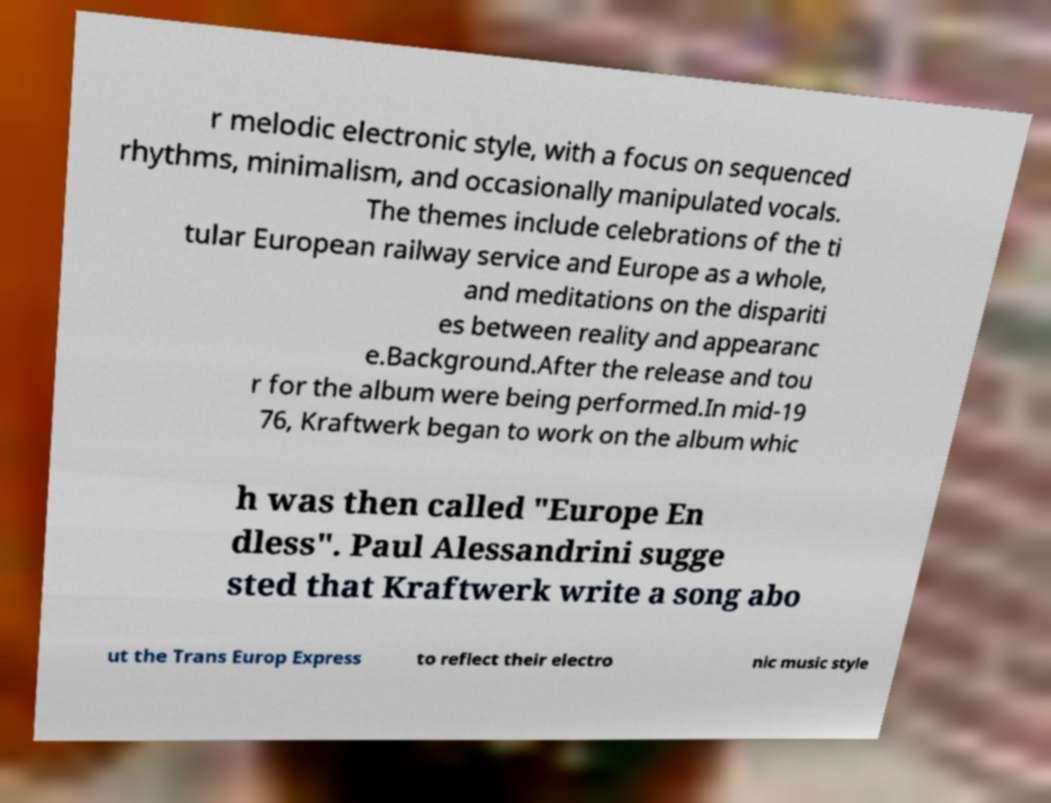For documentation purposes, I need the text within this image transcribed. Could you provide that? r melodic electronic style, with a focus on sequenced rhythms, minimalism, and occasionally manipulated vocals. The themes include celebrations of the ti tular European railway service and Europe as a whole, and meditations on the dispariti es between reality and appearanc e.Background.After the release and tou r for the album were being performed.In mid-19 76, Kraftwerk began to work on the album whic h was then called "Europe En dless". Paul Alessandrini sugge sted that Kraftwerk write a song abo ut the Trans Europ Express to reflect their electro nic music style 